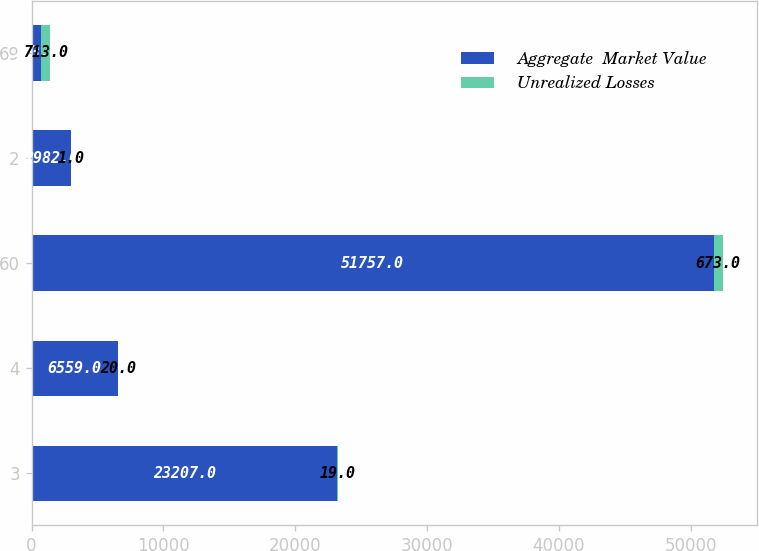Convert chart. <chart><loc_0><loc_0><loc_500><loc_500><stacked_bar_chart><ecel><fcel>3<fcel>4<fcel>60<fcel>2<fcel>69<nl><fcel>Aggregate  Market Value<fcel>23207<fcel>6559<fcel>51757<fcel>2982<fcel>713<nl><fcel>Unrealized Losses<fcel>19<fcel>20<fcel>673<fcel>1<fcel>713<nl></chart> 